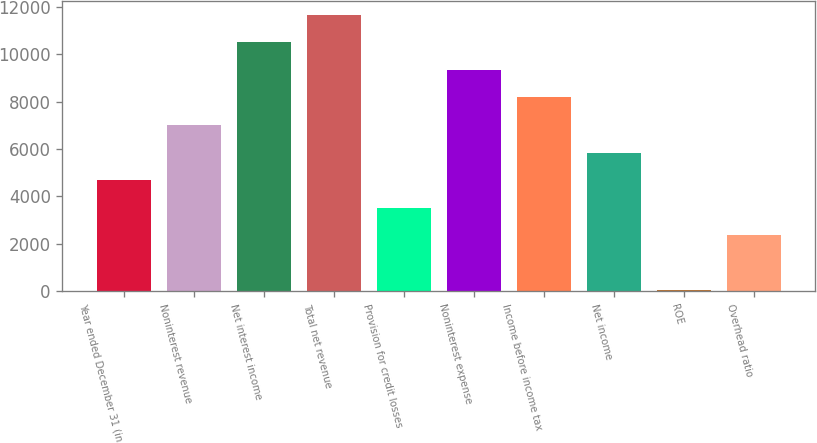Convert chart. <chart><loc_0><loc_0><loc_500><loc_500><bar_chart><fcel>Year ended December 31 (in<fcel>Noninterest revenue<fcel>Net interest income<fcel>Total net revenue<fcel>Provision for credit losses<fcel>Noninterest expense<fcel>Income before income tax<fcel>Net income<fcel>ROE<fcel>Overhead ratio<nl><fcel>4686.2<fcel>7013.8<fcel>10505.2<fcel>11669<fcel>3522.4<fcel>9341.4<fcel>8177.6<fcel>5850<fcel>31<fcel>2358.6<nl></chart> 